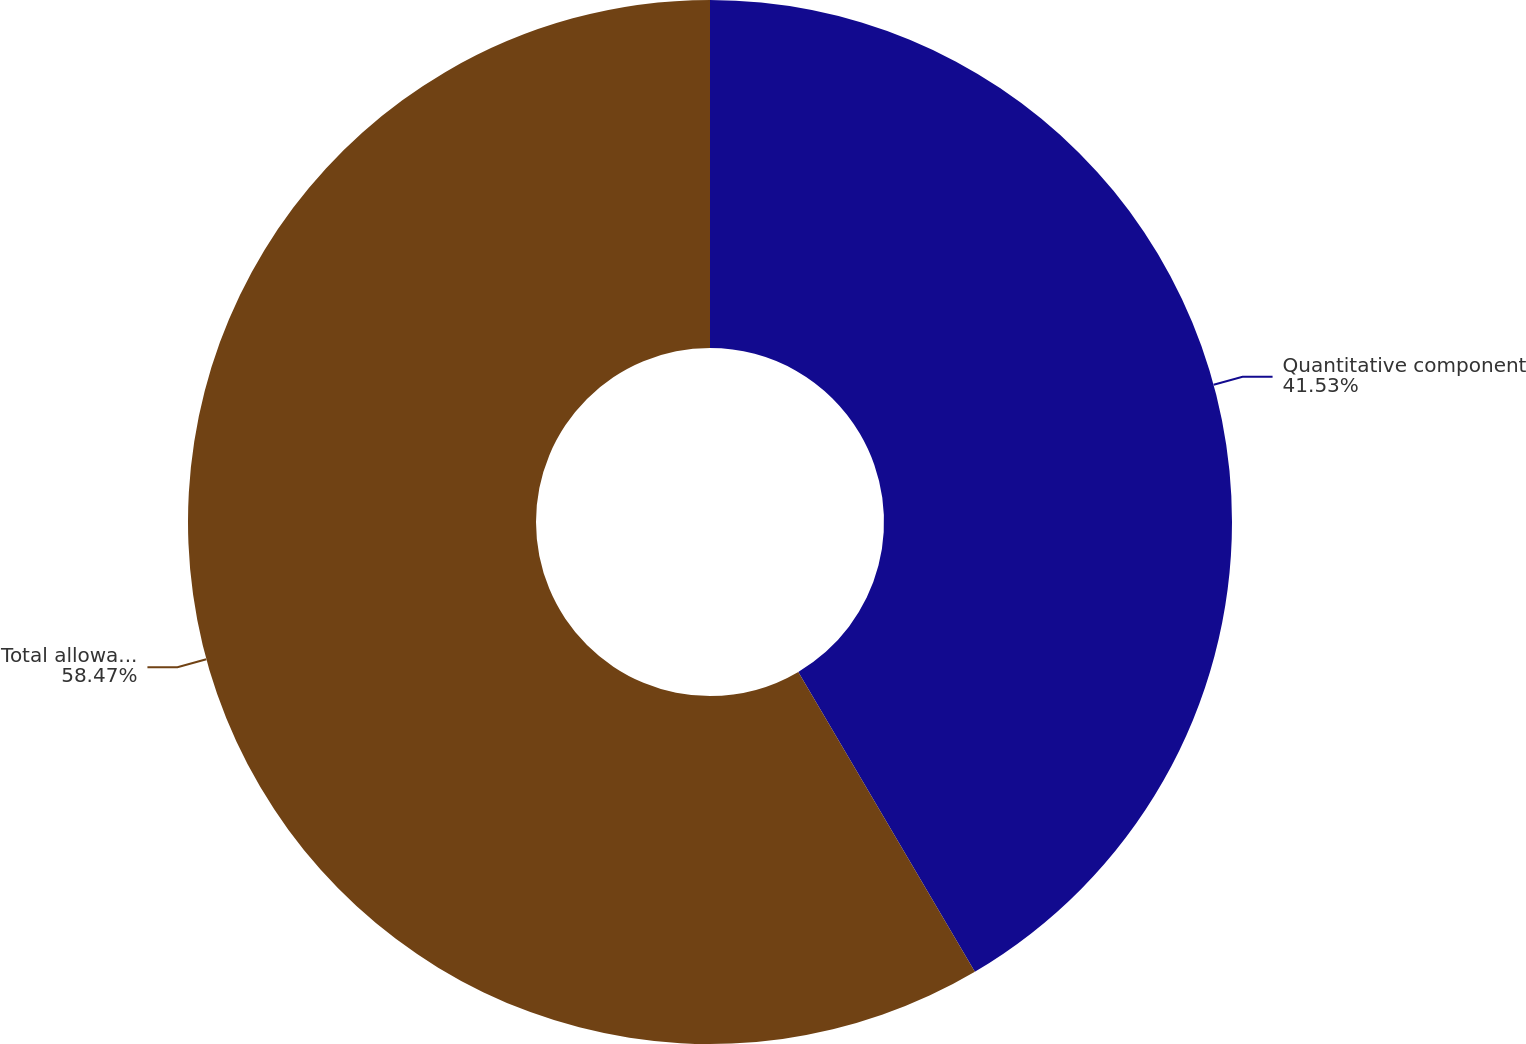<chart> <loc_0><loc_0><loc_500><loc_500><pie_chart><fcel>Quantitative component<fcel>Total allowance for loan<nl><fcel>41.53%<fcel>58.47%<nl></chart> 